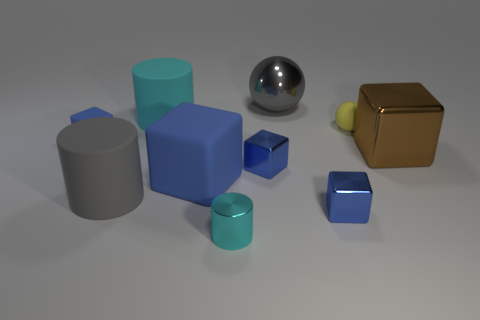Do the big rubber cube and the small matte block have the same color?
Make the answer very short. Yes. Is the size of the cyan matte object the same as the gray shiny sphere behind the big cyan rubber object?
Make the answer very short. Yes. There is a cube that is to the right of the tiny cyan cylinder and left of the large gray shiny ball; what is its size?
Keep it short and to the point. Small. Is there a large gray object that has the same material as the brown object?
Your response must be concise. Yes. What shape is the big blue object?
Provide a short and direct response. Cube. Do the gray metal thing and the brown cube have the same size?
Give a very brief answer. Yes. How many other things are the same shape as the big blue rubber thing?
Your response must be concise. 4. The large object that is right of the yellow matte ball has what shape?
Provide a succinct answer. Cube. There is a blue rubber thing left of the large gray matte thing; is its shape the same as the blue object on the right side of the gray ball?
Provide a short and direct response. Yes. Is the number of small blue blocks that are in front of the large brown thing the same as the number of large brown metallic blocks?
Your response must be concise. No. 